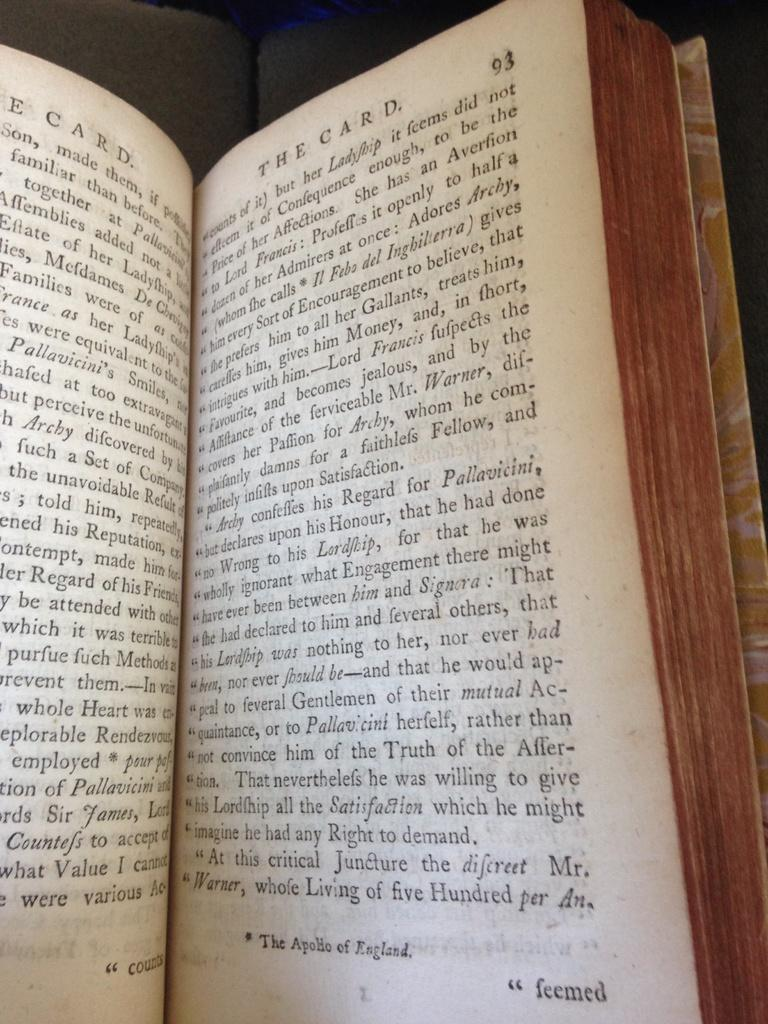<image>
Render a clear and concise summary of the photo. A book is opened to page 93 and is slightly worn. 